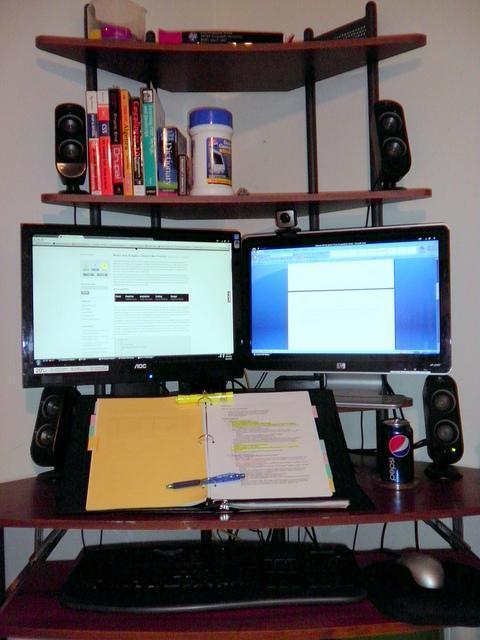How many monitors are on the desk?
Give a very brief answer. 2. How many tvs are in the photo?
Give a very brief answer. 2. 